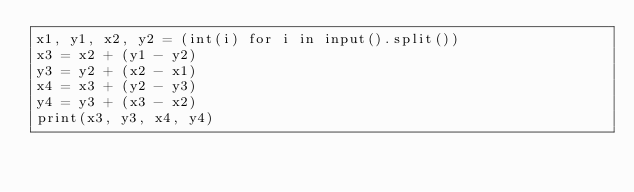Convert code to text. <code><loc_0><loc_0><loc_500><loc_500><_Python_>x1, y1, x2, y2 = (int(i) for i in input().split())
x3 = x2 + (y1 - y2)
y3 = y2 + (x2 - x1)
x4 = x3 + (y2 - y3)
y4 = y3 + (x3 - x2)
print(x3, y3, x4, y4)</code> 